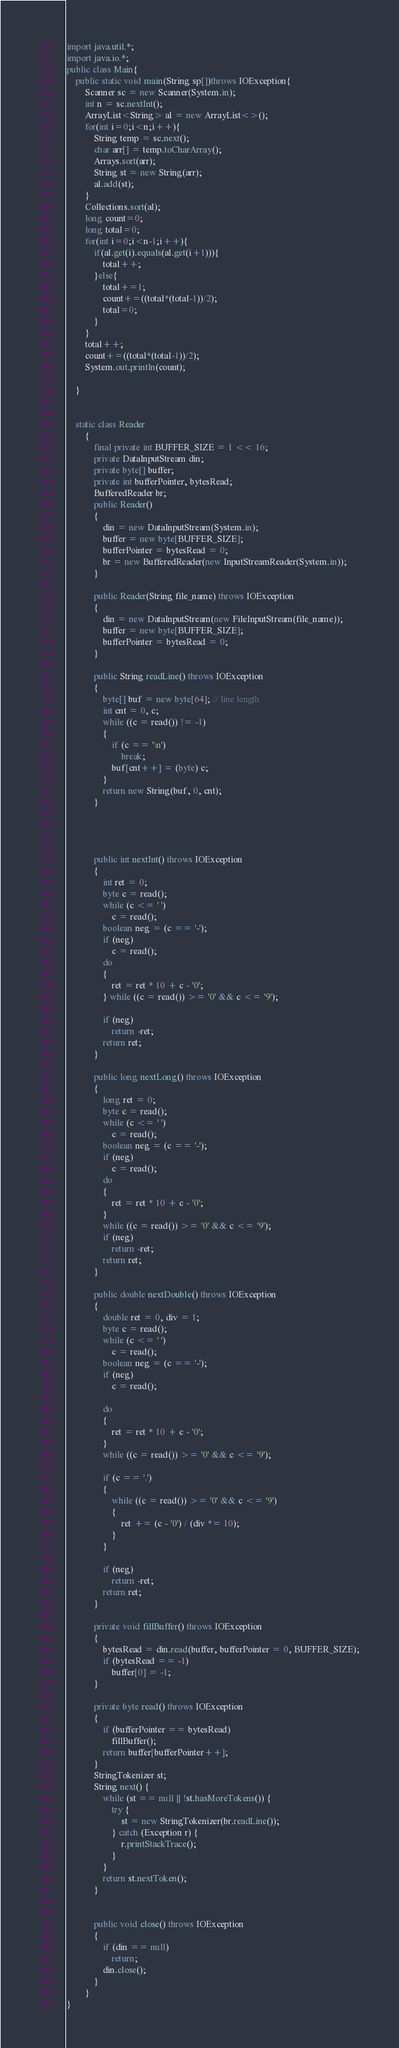<code> <loc_0><loc_0><loc_500><loc_500><_Java_>import java.util.*;
import java.io.*;
public class Main{
	public static void main(String sp[])throws IOException{
		Scanner sc = new Scanner(System.in);
		int n = sc.nextInt();
		ArrayList<String> al = new ArrayList<>();
		for(int i=0;i<n;i++){
			String temp = sc.next();
			char arr[] = temp.toCharArray();
			Arrays.sort(arr);
			String st = new String(arr);
			al.add(st);
		}
		Collections.sort(al);
		long count=0;
		long total=0;
		for(int i=0;i<n-1;i++){
			if(al.get(i).equals(al.get(i+1))){
				total++;
			}else{
				total+=1;
				count+=((total*(total-1))/2);
				total=0;
			}
		}
		total++;
		count+=((total*(total-1))/2);
		System.out.println(count);
		
	}
	
	
	static class Reader
		{
			final private int BUFFER_SIZE = 1 << 16;
			private DataInputStream din;
			private byte[] buffer;
			private int bufferPointer, bytesRead;
			BufferedReader br;
			public Reader()
			{
				din = new DataInputStream(System.in);
				buffer = new byte[BUFFER_SIZE];
				bufferPointer = bytesRead = 0;
				br = new BufferedReader(new InputStreamReader(System.in));
			}
	 
			public Reader(String file_name) throws IOException
			{
				din = new DataInputStream(new FileInputStream(file_name));
				buffer = new byte[BUFFER_SIZE];
				bufferPointer = bytesRead = 0;
			}
	 
			public String readLine() throws IOException
			{
				byte[] buf = new byte[64]; // line length
				int cnt = 0, c;
				while ((c = read()) != -1)
				{
					if (c == '\n')
						break;
					buf[cnt++] = (byte) c;
				}
				return new String(buf, 0, cnt);
			}
			
			
			
	 
			public int nextInt() throws IOException
			{
				int ret = 0;
				byte c = read();
				while (c <= ' ')
					c = read();
				boolean neg = (c == '-');
				if (neg)
					c = read();
				do
				{
					ret = ret * 10 + c - '0';
				} while ((c = read()) >= '0' && c <= '9');
	 
				if (neg)
					return -ret;
				return ret;
			}
	 
			public long nextLong() throws IOException
			{
				long ret = 0;
				byte c = read();
				while (c <= ' ')
					c = read();
				boolean neg = (c == '-');
				if (neg)
					c = read();
				do
				{
					ret = ret * 10 + c - '0';
				}
				while ((c = read()) >= '0' && c <= '9');
				if (neg)
					return -ret;
				return ret;
			}
	 
			public double nextDouble() throws IOException
			{
				double ret = 0, div = 1;
				byte c = read();
				while (c <= ' ')
					c = read();
				boolean neg = (c == '-');
				if (neg)
					c = read();
	 
				do
				{
					ret = ret * 10 + c - '0';
				}
				while ((c = read()) >= '0' && c <= '9');
	 
				if (c == '.')
				{
					while ((c = read()) >= '0' && c <= '9')
					{
						ret += (c - '0') / (div *= 10);
					}
				}
	 
				if (neg)
					return -ret;
				return ret;
			}
	 
			private void fillBuffer() throws IOException
			{
				bytesRead = din.read(buffer, bufferPointer = 0, BUFFER_SIZE);
				if (bytesRead == -1)
					buffer[0] = -1;
			}
	 
			private byte read() throws IOException
			{
				if (bufferPointer == bytesRead)
					fillBuffer();
				return buffer[bufferPointer++];
			}
			StringTokenizer st;
			String next() {
				while (st == null || !st.hasMoreTokens()) {
					try {
						st = new StringTokenizer(br.readLine());
					} catch (Exception r) {
						r.printStackTrace();
					}
				}
				return st.nextToken();
			}
	 
	 
			public void close() throws IOException
			{
				if (din == null)
					return;
				din.close();
			}
		}
}</code> 